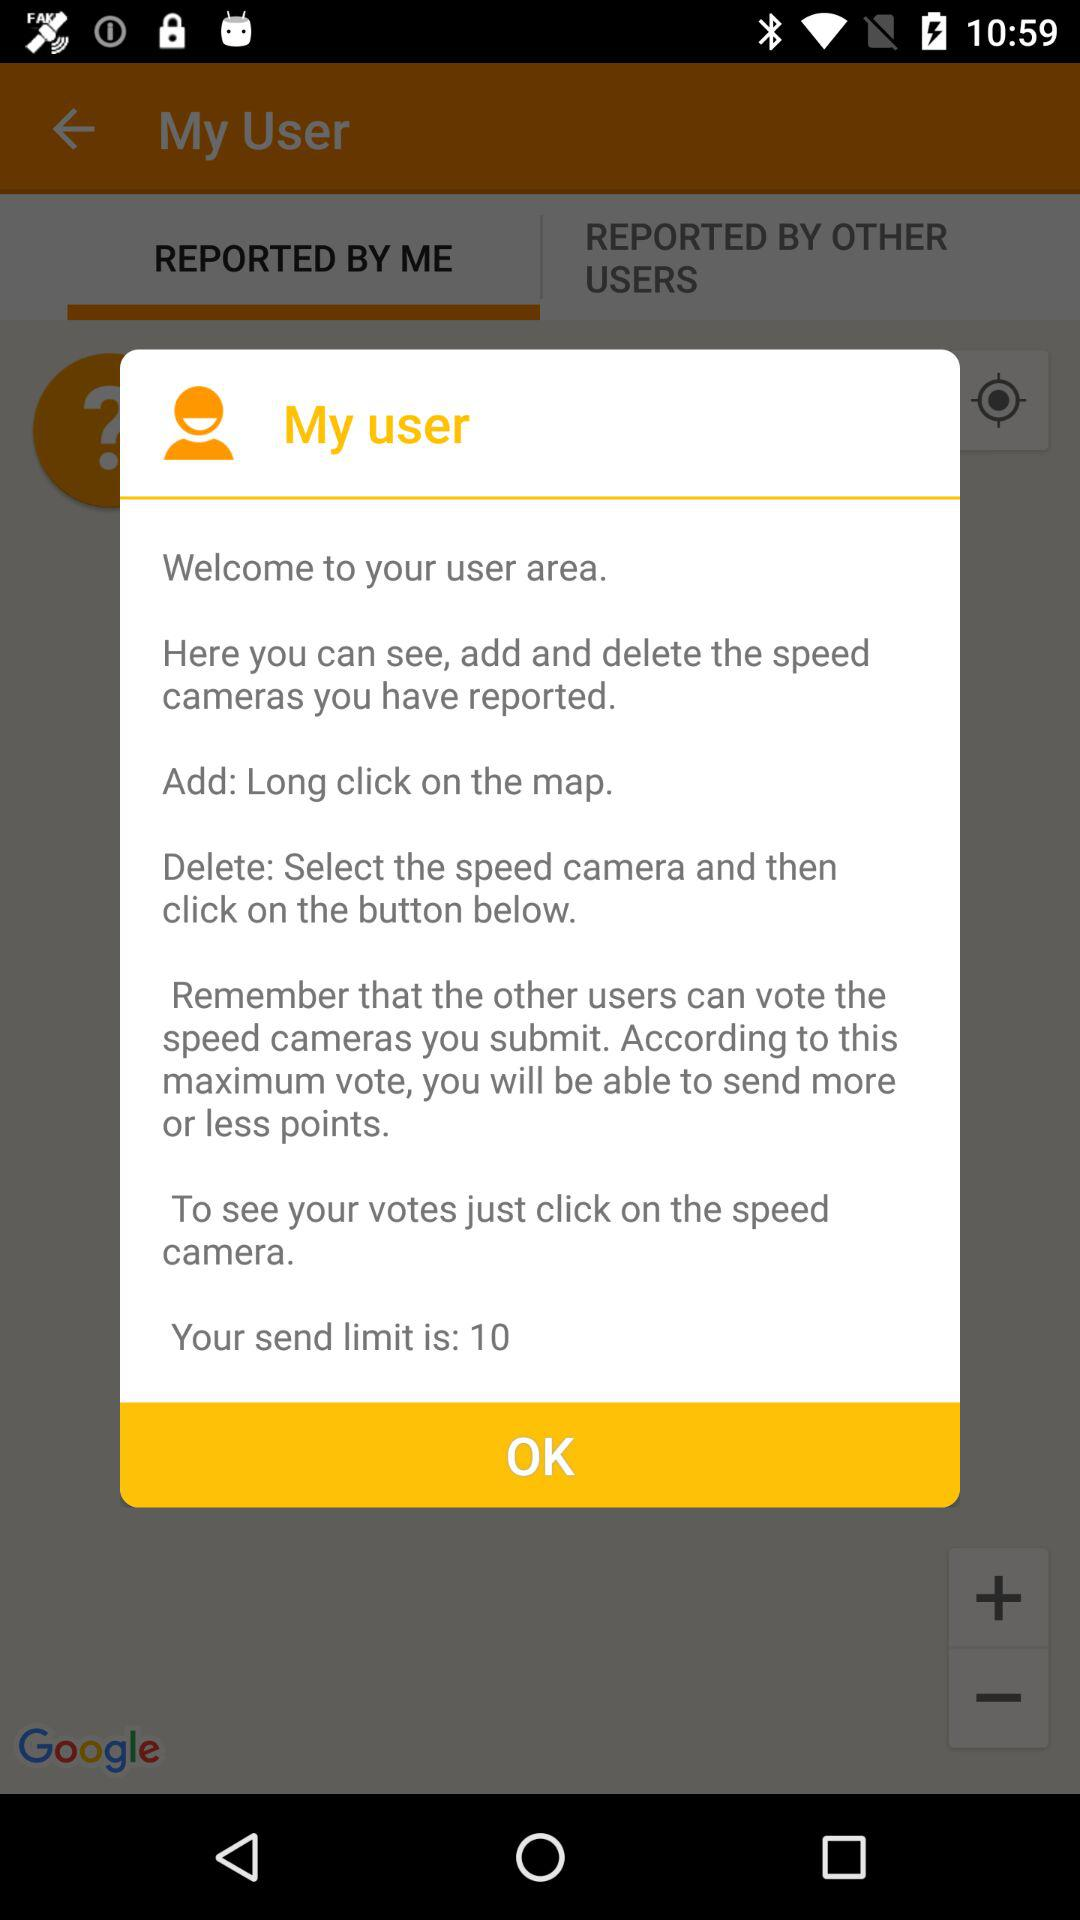What can we do in the user area? You can see, add and delete the speed cameras you have reported in the user area. 